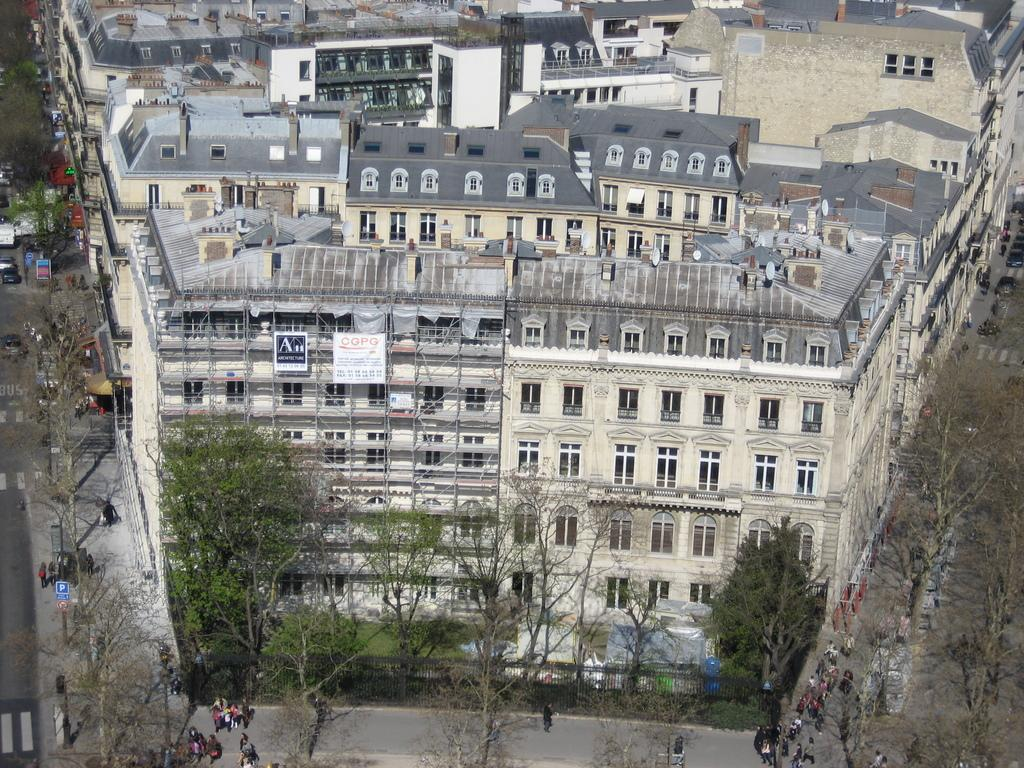What type of structures can be seen in the image? There are buildings in the image. What are the people in the image doing? People are walking on the road at the bottom of the image. What else can be seen moving in the image? There are vehicles in the image. What type of vegetation is present in the image? Trees are present in the front of the image. What is the surface that the people and vehicles are using in the image? There is a road at the bottom of the image. Where is the map located in the image? There is no map present in the image. What type of match is being played on the road in the image? There is no match being played in the image; people are simply walking on the road. 